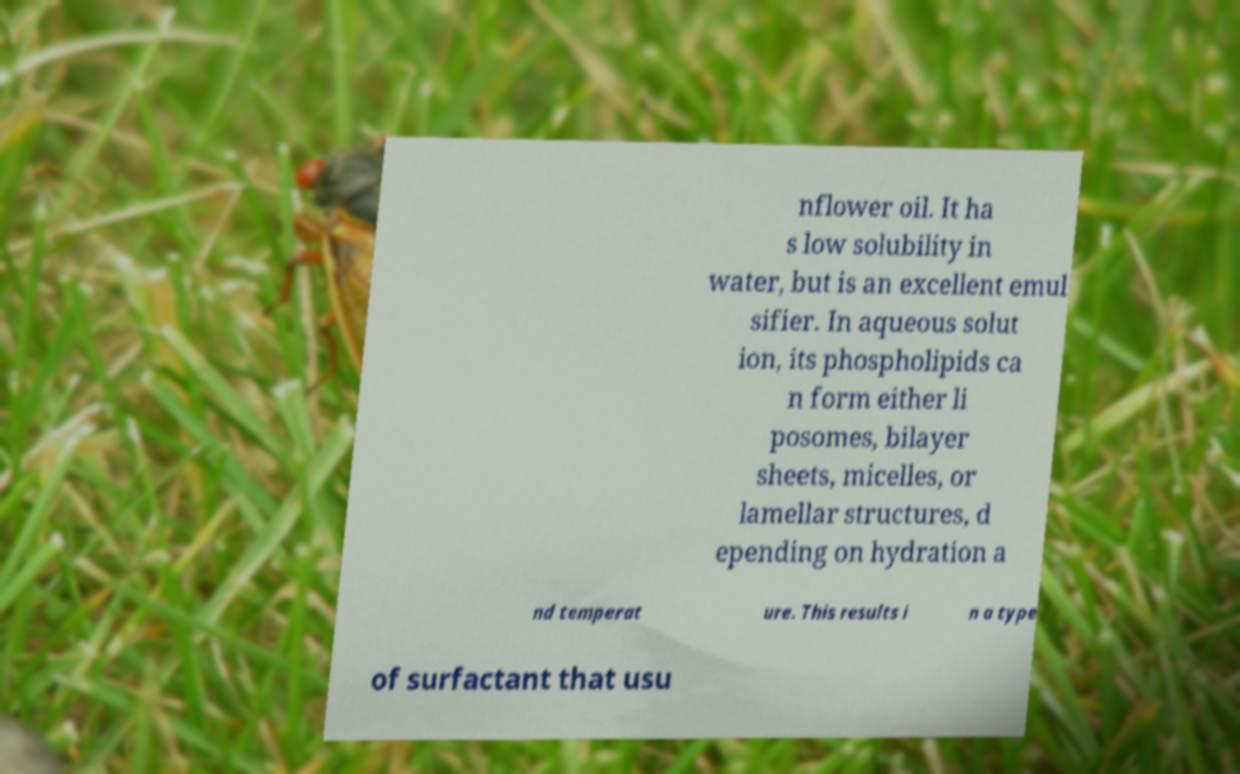What messages or text are displayed in this image? I need them in a readable, typed format. nflower oil. It ha s low solubility in water, but is an excellent emul sifier. In aqueous solut ion, its phospholipids ca n form either li posomes, bilayer sheets, micelles, or lamellar structures, d epending on hydration a nd temperat ure. This results i n a type of surfactant that usu 